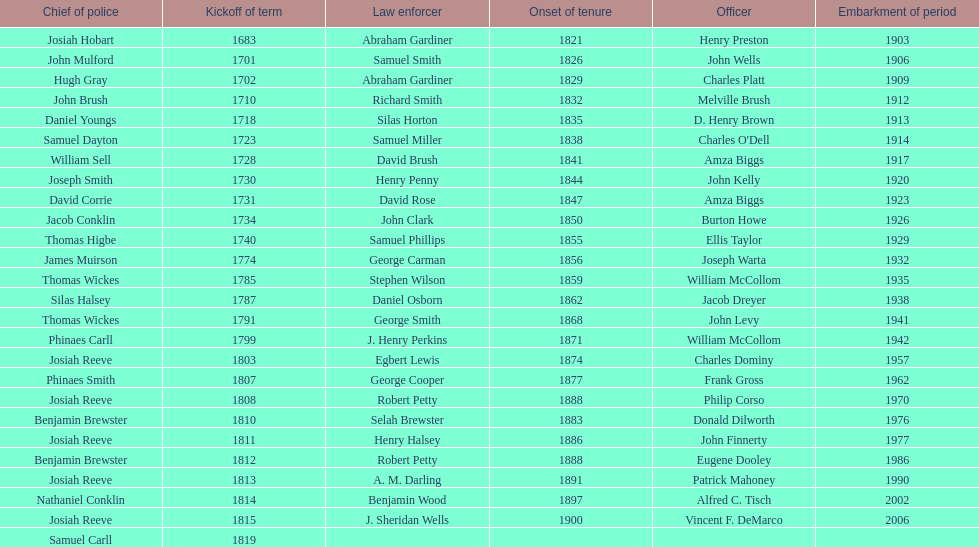When did benjamin brewster serve his second term? 1812. Would you be able to parse every entry in this table? {'header': ['Chief of police', 'Kickoff of term', 'Law enforcer', 'Onset of tenure', 'Officer', 'Embarkment of period'], 'rows': [['Josiah Hobart', '1683', 'Abraham Gardiner', '1821', 'Henry Preston', '1903'], ['John Mulford', '1701', 'Samuel Smith', '1826', 'John Wells', '1906'], ['Hugh Gray', '1702', 'Abraham Gardiner', '1829', 'Charles Platt', '1909'], ['John Brush', '1710', 'Richard Smith', '1832', 'Melville Brush', '1912'], ['Daniel Youngs', '1718', 'Silas Horton', '1835', 'D. Henry Brown', '1913'], ['Samuel Dayton', '1723', 'Samuel Miller', '1838', "Charles O'Dell", '1914'], ['William Sell', '1728', 'David Brush', '1841', 'Amza Biggs', '1917'], ['Joseph Smith', '1730', 'Henry Penny', '1844', 'John Kelly', '1920'], ['David Corrie', '1731', 'David Rose', '1847', 'Amza Biggs', '1923'], ['Jacob Conklin', '1734', 'John Clark', '1850', 'Burton Howe', '1926'], ['Thomas Higbe', '1740', 'Samuel Phillips', '1855', 'Ellis Taylor', '1929'], ['James Muirson', '1774', 'George Carman', '1856', 'Joseph Warta', '1932'], ['Thomas Wickes', '1785', 'Stephen Wilson', '1859', 'William McCollom', '1935'], ['Silas Halsey', '1787', 'Daniel Osborn', '1862', 'Jacob Dreyer', '1938'], ['Thomas Wickes', '1791', 'George Smith', '1868', 'John Levy', '1941'], ['Phinaes Carll', '1799', 'J. Henry Perkins', '1871', 'William McCollom', '1942'], ['Josiah Reeve', '1803', 'Egbert Lewis', '1874', 'Charles Dominy', '1957'], ['Phinaes Smith', '1807', 'George Cooper', '1877', 'Frank Gross', '1962'], ['Josiah Reeve', '1808', 'Robert Petty', '1888', 'Philip Corso', '1970'], ['Benjamin Brewster', '1810', 'Selah Brewster', '1883', 'Donald Dilworth', '1976'], ['Josiah Reeve', '1811', 'Henry Halsey', '1886', 'John Finnerty', '1977'], ['Benjamin Brewster', '1812', 'Robert Petty', '1888', 'Eugene Dooley', '1986'], ['Josiah Reeve', '1813', 'A. M. Darling', '1891', 'Patrick Mahoney', '1990'], ['Nathaniel Conklin', '1814', 'Benjamin Wood', '1897', 'Alfred C. Tisch', '2002'], ['Josiah Reeve', '1815', 'J. Sheridan Wells', '1900', 'Vincent F. DeMarco', '2006'], ['Samuel Carll', '1819', '', '', '', '']]} 